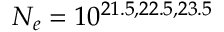<formula> <loc_0><loc_0><loc_500><loc_500>N _ { e } = 1 0 ^ { 2 1 . 5 , 2 2 . 5 , 2 3 . 5 }</formula> 